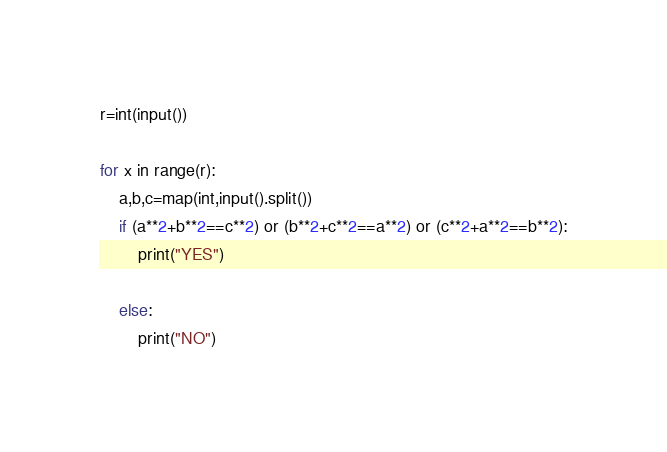Convert code to text. <code><loc_0><loc_0><loc_500><loc_500><_Python_>r=int(input())

for x in range(r):
    a,b,c=map(int,input().split())
    if (a**2+b**2==c**2) or (b**2+c**2==a**2) or (c**2+a**2==b**2):
        print("YES")
    
    else:
        print("NO")
</code> 